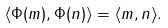Convert formula to latex. <formula><loc_0><loc_0><loc_500><loc_500>\langle \Phi ( m ) , \Phi ( n ) \rangle = \langle m , n \rangle .</formula> 